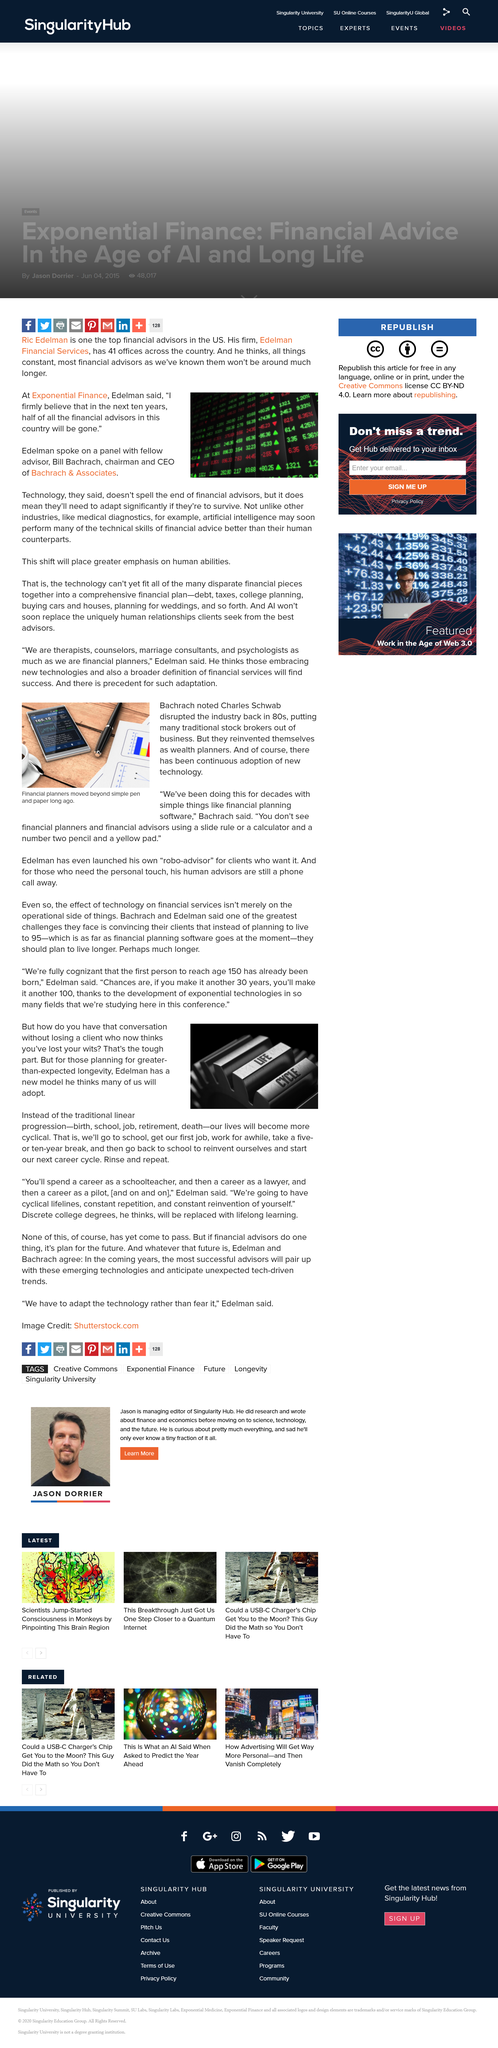List a handful of essential elements in this visual. The stock brokering industry was disrupted by Charles Schwab in the 1980's. The highest age mentioned in the article is 150 years. Edelman Financial Services is the financial firm of Ric Edelman, known for providing financial advice and planning to individuals and families. The chairman and CEO of Bachrach & Associates is Bill Bachrach. The last item on the traditional linear progression is death. 